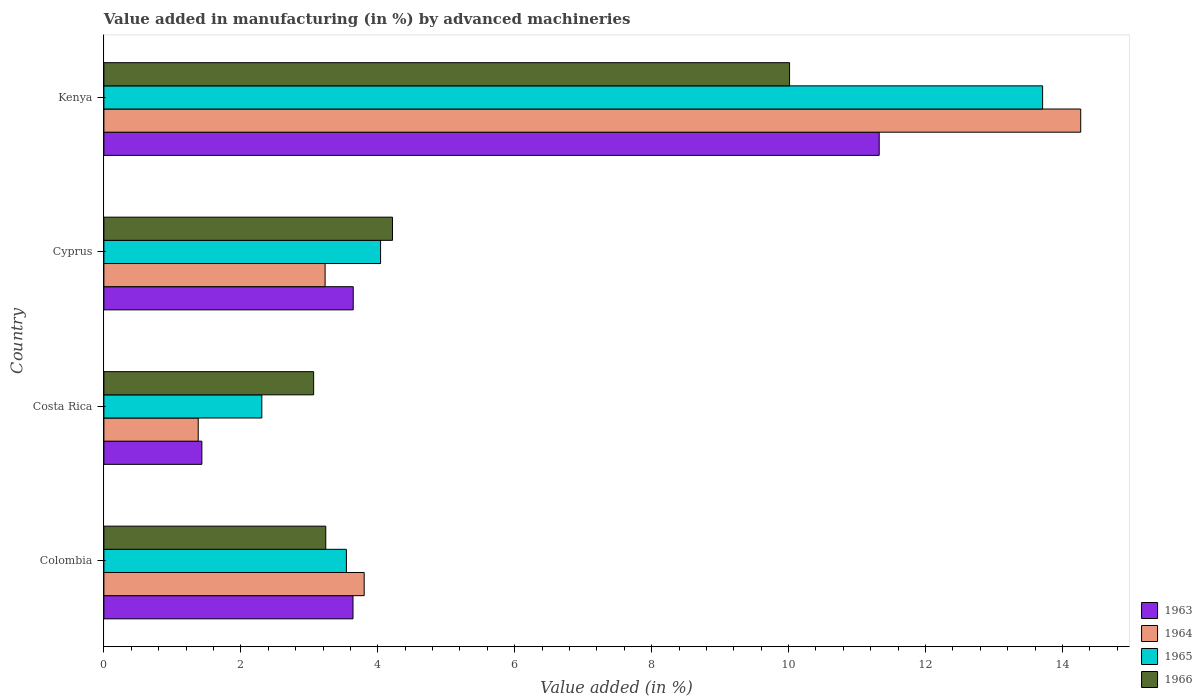How many different coloured bars are there?
Your response must be concise. 4. What is the label of the 1st group of bars from the top?
Offer a very short reply. Kenya. What is the percentage of value added in manufacturing by advanced machineries in 1965 in Costa Rica?
Provide a short and direct response. 2.31. Across all countries, what is the maximum percentage of value added in manufacturing by advanced machineries in 1964?
Your answer should be very brief. 14.27. Across all countries, what is the minimum percentage of value added in manufacturing by advanced machineries in 1966?
Your response must be concise. 3.06. In which country was the percentage of value added in manufacturing by advanced machineries in 1963 maximum?
Ensure brevity in your answer.  Kenya. What is the total percentage of value added in manufacturing by advanced machineries in 1963 in the graph?
Offer a very short reply. 20.03. What is the difference between the percentage of value added in manufacturing by advanced machineries in 1964 in Cyprus and that in Kenya?
Provide a succinct answer. -11.04. What is the difference between the percentage of value added in manufacturing by advanced machineries in 1964 in Cyprus and the percentage of value added in manufacturing by advanced machineries in 1963 in Costa Rica?
Offer a terse response. 1.8. What is the average percentage of value added in manufacturing by advanced machineries in 1966 per country?
Ensure brevity in your answer.  5.13. What is the difference between the percentage of value added in manufacturing by advanced machineries in 1964 and percentage of value added in manufacturing by advanced machineries in 1965 in Cyprus?
Offer a very short reply. -0.81. In how many countries, is the percentage of value added in manufacturing by advanced machineries in 1964 greater than 5.6 %?
Your response must be concise. 1. What is the ratio of the percentage of value added in manufacturing by advanced machineries in 1963 in Colombia to that in Costa Rica?
Keep it short and to the point. 2.54. Is the percentage of value added in manufacturing by advanced machineries in 1965 in Cyprus less than that in Kenya?
Your answer should be very brief. Yes. Is the difference between the percentage of value added in manufacturing by advanced machineries in 1964 in Colombia and Kenya greater than the difference between the percentage of value added in manufacturing by advanced machineries in 1965 in Colombia and Kenya?
Make the answer very short. No. What is the difference between the highest and the second highest percentage of value added in manufacturing by advanced machineries in 1965?
Provide a succinct answer. 9.67. What is the difference between the highest and the lowest percentage of value added in manufacturing by advanced machineries in 1965?
Provide a short and direct response. 11.4. What does the 3rd bar from the top in Colombia represents?
Offer a very short reply. 1964. What does the 4th bar from the bottom in Kenya represents?
Provide a short and direct response. 1966. Is it the case that in every country, the sum of the percentage of value added in manufacturing by advanced machineries in 1963 and percentage of value added in manufacturing by advanced machineries in 1966 is greater than the percentage of value added in manufacturing by advanced machineries in 1964?
Your answer should be compact. Yes. Are all the bars in the graph horizontal?
Keep it short and to the point. Yes. What is the difference between two consecutive major ticks on the X-axis?
Your answer should be compact. 2. Are the values on the major ticks of X-axis written in scientific E-notation?
Give a very brief answer. No. Does the graph contain any zero values?
Provide a succinct answer. No. Does the graph contain grids?
Ensure brevity in your answer.  No. How many legend labels are there?
Offer a terse response. 4. How are the legend labels stacked?
Keep it short and to the point. Vertical. What is the title of the graph?
Offer a terse response. Value added in manufacturing (in %) by advanced machineries. What is the label or title of the X-axis?
Provide a succinct answer. Value added (in %). What is the label or title of the Y-axis?
Your answer should be very brief. Country. What is the Value added (in %) in 1963 in Colombia?
Give a very brief answer. 3.64. What is the Value added (in %) in 1964 in Colombia?
Your answer should be compact. 3.8. What is the Value added (in %) of 1965 in Colombia?
Your answer should be very brief. 3.54. What is the Value added (in %) in 1966 in Colombia?
Keep it short and to the point. 3.24. What is the Value added (in %) in 1963 in Costa Rica?
Offer a terse response. 1.43. What is the Value added (in %) in 1964 in Costa Rica?
Provide a short and direct response. 1.38. What is the Value added (in %) in 1965 in Costa Rica?
Give a very brief answer. 2.31. What is the Value added (in %) of 1966 in Costa Rica?
Your answer should be compact. 3.06. What is the Value added (in %) in 1963 in Cyprus?
Your answer should be compact. 3.64. What is the Value added (in %) in 1964 in Cyprus?
Provide a succinct answer. 3.23. What is the Value added (in %) of 1965 in Cyprus?
Make the answer very short. 4.04. What is the Value added (in %) of 1966 in Cyprus?
Your answer should be very brief. 4.22. What is the Value added (in %) of 1963 in Kenya?
Your response must be concise. 11.32. What is the Value added (in %) of 1964 in Kenya?
Keep it short and to the point. 14.27. What is the Value added (in %) in 1965 in Kenya?
Give a very brief answer. 13.71. What is the Value added (in %) of 1966 in Kenya?
Keep it short and to the point. 10.01. Across all countries, what is the maximum Value added (in %) in 1963?
Offer a very short reply. 11.32. Across all countries, what is the maximum Value added (in %) in 1964?
Keep it short and to the point. 14.27. Across all countries, what is the maximum Value added (in %) of 1965?
Give a very brief answer. 13.71. Across all countries, what is the maximum Value added (in %) of 1966?
Provide a succinct answer. 10.01. Across all countries, what is the minimum Value added (in %) of 1963?
Your answer should be very brief. 1.43. Across all countries, what is the minimum Value added (in %) of 1964?
Your response must be concise. 1.38. Across all countries, what is the minimum Value added (in %) of 1965?
Make the answer very short. 2.31. Across all countries, what is the minimum Value added (in %) of 1966?
Offer a very short reply. 3.06. What is the total Value added (in %) in 1963 in the graph?
Offer a very short reply. 20.03. What is the total Value added (in %) in 1964 in the graph?
Give a very brief answer. 22.68. What is the total Value added (in %) in 1965 in the graph?
Offer a terse response. 23.6. What is the total Value added (in %) in 1966 in the graph?
Provide a succinct answer. 20.53. What is the difference between the Value added (in %) in 1963 in Colombia and that in Costa Rica?
Ensure brevity in your answer.  2.21. What is the difference between the Value added (in %) of 1964 in Colombia and that in Costa Rica?
Offer a very short reply. 2.42. What is the difference between the Value added (in %) in 1965 in Colombia and that in Costa Rica?
Keep it short and to the point. 1.24. What is the difference between the Value added (in %) in 1966 in Colombia and that in Costa Rica?
Provide a succinct answer. 0.18. What is the difference between the Value added (in %) of 1963 in Colombia and that in Cyprus?
Your response must be concise. -0. What is the difference between the Value added (in %) of 1964 in Colombia and that in Cyprus?
Make the answer very short. 0.57. What is the difference between the Value added (in %) in 1965 in Colombia and that in Cyprus?
Your answer should be compact. -0.5. What is the difference between the Value added (in %) in 1966 in Colombia and that in Cyprus?
Keep it short and to the point. -0.97. What is the difference between the Value added (in %) in 1963 in Colombia and that in Kenya?
Make the answer very short. -7.69. What is the difference between the Value added (in %) of 1964 in Colombia and that in Kenya?
Give a very brief answer. -10.47. What is the difference between the Value added (in %) in 1965 in Colombia and that in Kenya?
Offer a terse response. -10.17. What is the difference between the Value added (in %) in 1966 in Colombia and that in Kenya?
Keep it short and to the point. -6.77. What is the difference between the Value added (in %) in 1963 in Costa Rica and that in Cyprus?
Offer a terse response. -2.21. What is the difference between the Value added (in %) of 1964 in Costa Rica and that in Cyprus?
Provide a succinct answer. -1.85. What is the difference between the Value added (in %) in 1965 in Costa Rica and that in Cyprus?
Ensure brevity in your answer.  -1.73. What is the difference between the Value added (in %) in 1966 in Costa Rica and that in Cyprus?
Your answer should be very brief. -1.15. What is the difference between the Value added (in %) in 1963 in Costa Rica and that in Kenya?
Give a very brief answer. -9.89. What is the difference between the Value added (in %) in 1964 in Costa Rica and that in Kenya?
Your answer should be very brief. -12.89. What is the difference between the Value added (in %) of 1965 in Costa Rica and that in Kenya?
Offer a very short reply. -11.4. What is the difference between the Value added (in %) of 1966 in Costa Rica and that in Kenya?
Your answer should be compact. -6.95. What is the difference between the Value added (in %) of 1963 in Cyprus and that in Kenya?
Your answer should be very brief. -7.68. What is the difference between the Value added (in %) in 1964 in Cyprus and that in Kenya?
Your answer should be compact. -11.04. What is the difference between the Value added (in %) of 1965 in Cyprus and that in Kenya?
Offer a terse response. -9.67. What is the difference between the Value added (in %) of 1966 in Cyprus and that in Kenya?
Provide a short and direct response. -5.8. What is the difference between the Value added (in %) of 1963 in Colombia and the Value added (in %) of 1964 in Costa Rica?
Give a very brief answer. 2.26. What is the difference between the Value added (in %) of 1963 in Colombia and the Value added (in %) of 1965 in Costa Rica?
Make the answer very short. 1.33. What is the difference between the Value added (in %) of 1963 in Colombia and the Value added (in %) of 1966 in Costa Rica?
Provide a succinct answer. 0.57. What is the difference between the Value added (in %) of 1964 in Colombia and the Value added (in %) of 1965 in Costa Rica?
Offer a very short reply. 1.49. What is the difference between the Value added (in %) of 1964 in Colombia and the Value added (in %) of 1966 in Costa Rica?
Offer a terse response. 0.74. What is the difference between the Value added (in %) in 1965 in Colombia and the Value added (in %) in 1966 in Costa Rica?
Provide a succinct answer. 0.48. What is the difference between the Value added (in %) in 1963 in Colombia and the Value added (in %) in 1964 in Cyprus?
Your response must be concise. 0.41. What is the difference between the Value added (in %) in 1963 in Colombia and the Value added (in %) in 1965 in Cyprus?
Give a very brief answer. -0.4. What is the difference between the Value added (in %) of 1963 in Colombia and the Value added (in %) of 1966 in Cyprus?
Offer a very short reply. -0.58. What is the difference between the Value added (in %) of 1964 in Colombia and the Value added (in %) of 1965 in Cyprus?
Your response must be concise. -0.24. What is the difference between the Value added (in %) of 1964 in Colombia and the Value added (in %) of 1966 in Cyprus?
Your answer should be very brief. -0.41. What is the difference between the Value added (in %) of 1965 in Colombia and the Value added (in %) of 1966 in Cyprus?
Provide a succinct answer. -0.67. What is the difference between the Value added (in %) of 1963 in Colombia and the Value added (in %) of 1964 in Kenya?
Offer a terse response. -10.63. What is the difference between the Value added (in %) of 1963 in Colombia and the Value added (in %) of 1965 in Kenya?
Your answer should be very brief. -10.07. What is the difference between the Value added (in %) of 1963 in Colombia and the Value added (in %) of 1966 in Kenya?
Provide a succinct answer. -6.38. What is the difference between the Value added (in %) of 1964 in Colombia and the Value added (in %) of 1965 in Kenya?
Your answer should be very brief. -9.91. What is the difference between the Value added (in %) of 1964 in Colombia and the Value added (in %) of 1966 in Kenya?
Offer a terse response. -6.21. What is the difference between the Value added (in %) of 1965 in Colombia and the Value added (in %) of 1966 in Kenya?
Make the answer very short. -6.47. What is the difference between the Value added (in %) of 1963 in Costa Rica and the Value added (in %) of 1964 in Cyprus?
Ensure brevity in your answer.  -1.8. What is the difference between the Value added (in %) of 1963 in Costa Rica and the Value added (in %) of 1965 in Cyprus?
Make the answer very short. -2.61. What is the difference between the Value added (in %) of 1963 in Costa Rica and the Value added (in %) of 1966 in Cyprus?
Provide a short and direct response. -2.78. What is the difference between the Value added (in %) in 1964 in Costa Rica and the Value added (in %) in 1965 in Cyprus?
Your answer should be very brief. -2.66. What is the difference between the Value added (in %) in 1964 in Costa Rica and the Value added (in %) in 1966 in Cyprus?
Give a very brief answer. -2.84. What is the difference between the Value added (in %) in 1965 in Costa Rica and the Value added (in %) in 1966 in Cyprus?
Offer a terse response. -1.91. What is the difference between the Value added (in %) of 1963 in Costa Rica and the Value added (in %) of 1964 in Kenya?
Make the answer very short. -12.84. What is the difference between the Value added (in %) of 1963 in Costa Rica and the Value added (in %) of 1965 in Kenya?
Give a very brief answer. -12.28. What is the difference between the Value added (in %) in 1963 in Costa Rica and the Value added (in %) in 1966 in Kenya?
Your response must be concise. -8.58. What is the difference between the Value added (in %) of 1964 in Costa Rica and the Value added (in %) of 1965 in Kenya?
Provide a short and direct response. -12.33. What is the difference between the Value added (in %) in 1964 in Costa Rica and the Value added (in %) in 1966 in Kenya?
Offer a terse response. -8.64. What is the difference between the Value added (in %) in 1965 in Costa Rica and the Value added (in %) in 1966 in Kenya?
Make the answer very short. -7.71. What is the difference between the Value added (in %) in 1963 in Cyprus and the Value added (in %) in 1964 in Kenya?
Your answer should be very brief. -10.63. What is the difference between the Value added (in %) in 1963 in Cyprus and the Value added (in %) in 1965 in Kenya?
Your answer should be very brief. -10.07. What is the difference between the Value added (in %) in 1963 in Cyprus and the Value added (in %) in 1966 in Kenya?
Offer a terse response. -6.37. What is the difference between the Value added (in %) in 1964 in Cyprus and the Value added (in %) in 1965 in Kenya?
Offer a very short reply. -10.48. What is the difference between the Value added (in %) in 1964 in Cyprus and the Value added (in %) in 1966 in Kenya?
Your answer should be compact. -6.78. What is the difference between the Value added (in %) of 1965 in Cyprus and the Value added (in %) of 1966 in Kenya?
Give a very brief answer. -5.97. What is the average Value added (in %) in 1963 per country?
Provide a short and direct response. 5.01. What is the average Value added (in %) in 1964 per country?
Provide a short and direct response. 5.67. What is the average Value added (in %) in 1965 per country?
Provide a short and direct response. 5.9. What is the average Value added (in %) in 1966 per country?
Ensure brevity in your answer.  5.13. What is the difference between the Value added (in %) of 1963 and Value added (in %) of 1964 in Colombia?
Your response must be concise. -0.16. What is the difference between the Value added (in %) in 1963 and Value added (in %) in 1965 in Colombia?
Offer a very short reply. 0.1. What is the difference between the Value added (in %) in 1963 and Value added (in %) in 1966 in Colombia?
Make the answer very short. 0.4. What is the difference between the Value added (in %) of 1964 and Value added (in %) of 1965 in Colombia?
Your response must be concise. 0.26. What is the difference between the Value added (in %) in 1964 and Value added (in %) in 1966 in Colombia?
Your response must be concise. 0.56. What is the difference between the Value added (in %) in 1965 and Value added (in %) in 1966 in Colombia?
Give a very brief answer. 0.3. What is the difference between the Value added (in %) of 1963 and Value added (in %) of 1964 in Costa Rica?
Offer a very short reply. 0.05. What is the difference between the Value added (in %) of 1963 and Value added (in %) of 1965 in Costa Rica?
Offer a terse response. -0.88. What is the difference between the Value added (in %) in 1963 and Value added (in %) in 1966 in Costa Rica?
Your answer should be compact. -1.63. What is the difference between the Value added (in %) of 1964 and Value added (in %) of 1965 in Costa Rica?
Your answer should be very brief. -0.93. What is the difference between the Value added (in %) in 1964 and Value added (in %) in 1966 in Costa Rica?
Ensure brevity in your answer.  -1.69. What is the difference between the Value added (in %) of 1965 and Value added (in %) of 1966 in Costa Rica?
Provide a succinct answer. -0.76. What is the difference between the Value added (in %) of 1963 and Value added (in %) of 1964 in Cyprus?
Provide a succinct answer. 0.41. What is the difference between the Value added (in %) in 1963 and Value added (in %) in 1965 in Cyprus?
Keep it short and to the point. -0.4. What is the difference between the Value added (in %) of 1963 and Value added (in %) of 1966 in Cyprus?
Offer a terse response. -0.57. What is the difference between the Value added (in %) in 1964 and Value added (in %) in 1965 in Cyprus?
Your response must be concise. -0.81. What is the difference between the Value added (in %) of 1964 and Value added (in %) of 1966 in Cyprus?
Your answer should be compact. -0.98. What is the difference between the Value added (in %) in 1965 and Value added (in %) in 1966 in Cyprus?
Ensure brevity in your answer.  -0.17. What is the difference between the Value added (in %) in 1963 and Value added (in %) in 1964 in Kenya?
Your response must be concise. -2.94. What is the difference between the Value added (in %) in 1963 and Value added (in %) in 1965 in Kenya?
Offer a terse response. -2.39. What is the difference between the Value added (in %) of 1963 and Value added (in %) of 1966 in Kenya?
Ensure brevity in your answer.  1.31. What is the difference between the Value added (in %) of 1964 and Value added (in %) of 1965 in Kenya?
Offer a terse response. 0.56. What is the difference between the Value added (in %) in 1964 and Value added (in %) in 1966 in Kenya?
Offer a terse response. 4.25. What is the difference between the Value added (in %) of 1965 and Value added (in %) of 1966 in Kenya?
Your response must be concise. 3.7. What is the ratio of the Value added (in %) in 1963 in Colombia to that in Costa Rica?
Provide a short and direct response. 2.54. What is the ratio of the Value added (in %) of 1964 in Colombia to that in Costa Rica?
Give a very brief answer. 2.76. What is the ratio of the Value added (in %) of 1965 in Colombia to that in Costa Rica?
Provide a short and direct response. 1.54. What is the ratio of the Value added (in %) in 1966 in Colombia to that in Costa Rica?
Make the answer very short. 1.06. What is the ratio of the Value added (in %) of 1963 in Colombia to that in Cyprus?
Provide a succinct answer. 1. What is the ratio of the Value added (in %) of 1964 in Colombia to that in Cyprus?
Give a very brief answer. 1.18. What is the ratio of the Value added (in %) of 1965 in Colombia to that in Cyprus?
Offer a terse response. 0.88. What is the ratio of the Value added (in %) of 1966 in Colombia to that in Cyprus?
Keep it short and to the point. 0.77. What is the ratio of the Value added (in %) in 1963 in Colombia to that in Kenya?
Your answer should be compact. 0.32. What is the ratio of the Value added (in %) of 1964 in Colombia to that in Kenya?
Make the answer very short. 0.27. What is the ratio of the Value added (in %) of 1965 in Colombia to that in Kenya?
Make the answer very short. 0.26. What is the ratio of the Value added (in %) of 1966 in Colombia to that in Kenya?
Your answer should be very brief. 0.32. What is the ratio of the Value added (in %) in 1963 in Costa Rica to that in Cyprus?
Make the answer very short. 0.39. What is the ratio of the Value added (in %) in 1964 in Costa Rica to that in Cyprus?
Make the answer very short. 0.43. What is the ratio of the Value added (in %) in 1965 in Costa Rica to that in Cyprus?
Offer a terse response. 0.57. What is the ratio of the Value added (in %) in 1966 in Costa Rica to that in Cyprus?
Offer a very short reply. 0.73. What is the ratio of the Value added (in %) in 1963 in Costa Rica to that in Kenya?
Give a very brief answer. 0.13. What is the ratio of the Value added (in %) of 1964 in Costa Rica to that in Kenya?
Your answer should be compact. 0.1. What is the ratio of the Value added (in %) of 1965 in Costa Rica to that in Kenya?
Your response must be concise. 0.17. What is the ratio of the Value added (in %) of 1966 in Costa Rica to that in Kenya?
Make the answer very short. 0.31. What is the ratio of the Value added (in %) of 1963 in Cyprus to that in Kenya?
Your answer should be very brief. 0.32. What is the ratio of the Value added (in %) in 1964 in Cyprus to that in Kenya?
Provide a succinct answer. 0.23. What is the ratio of the Value added (in %) in 1965 in Cyprus to that in Kenya?
Your answer should be compact. 0.29. What is the ratio of the Value added (in %) in 1966 in Cyprus to that in Kenya?
Your answer should be very brief. 0.42. What is the difference between the highest and the second highest Value added (in %) of 1963?
Offer a terse response. 7.68. What is the difference between the highest and the second highest Value added (in %) in 1964?
Provide a short and direct response. 10.47. What is the difference between the highest and the second highest Value added (in %) in 1965?
Your answer should be compact. 9.67. What is the difference between the highest and the second highest Value added (in %) in 1966?
Keep it short and to the point. 5.8. What is the difference between the highest and the lowest Value added (in %) of 1963?
Give a very brief answer. 9.89. What is the difference between the highest and the lowest Value added (in %) of 1964?
Give a very brief answer. 12.89. What is the difference between the highest and the lowest Value added (in %) in 1965?
Make the answer very short. 11.4. What is the difference between the highest and the lowest Value added (in %) of 1966?
Your answer should be very brief. 6.95. 